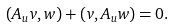<formula> <loc_0><loc_0><loc_500><loc_500>( A _ { u } v , w ) + ( v , A _ { u } w ) = 0 .</formula> 